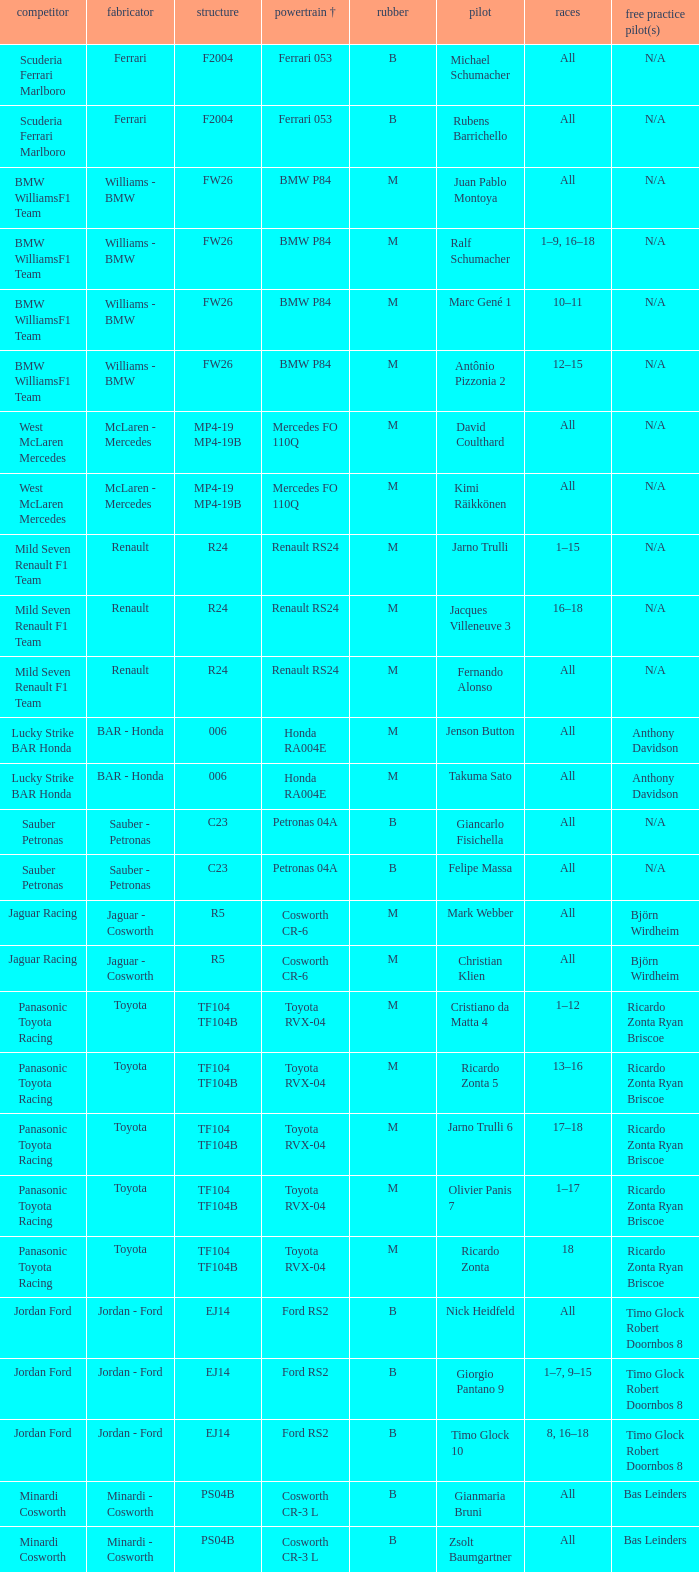What are the rounds for the B tyres and Ferrari 053 engine +? All, All. 